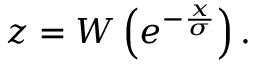Convert formula to latex. <formula><loc_0><loc_0><loc_500><loc_500>z = W \left ( e ^ { - { \frac { x } { \sigma } } } \right ) .</formula> 